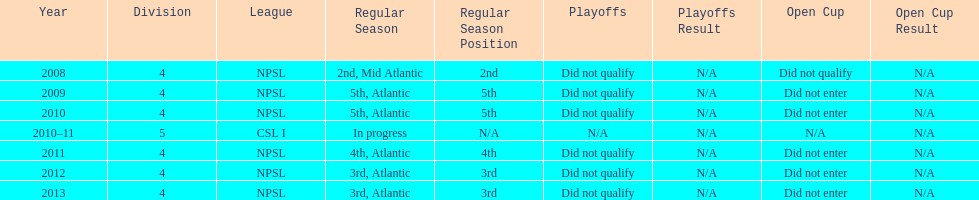How many years did they not qualify for the playoffs? 6. 